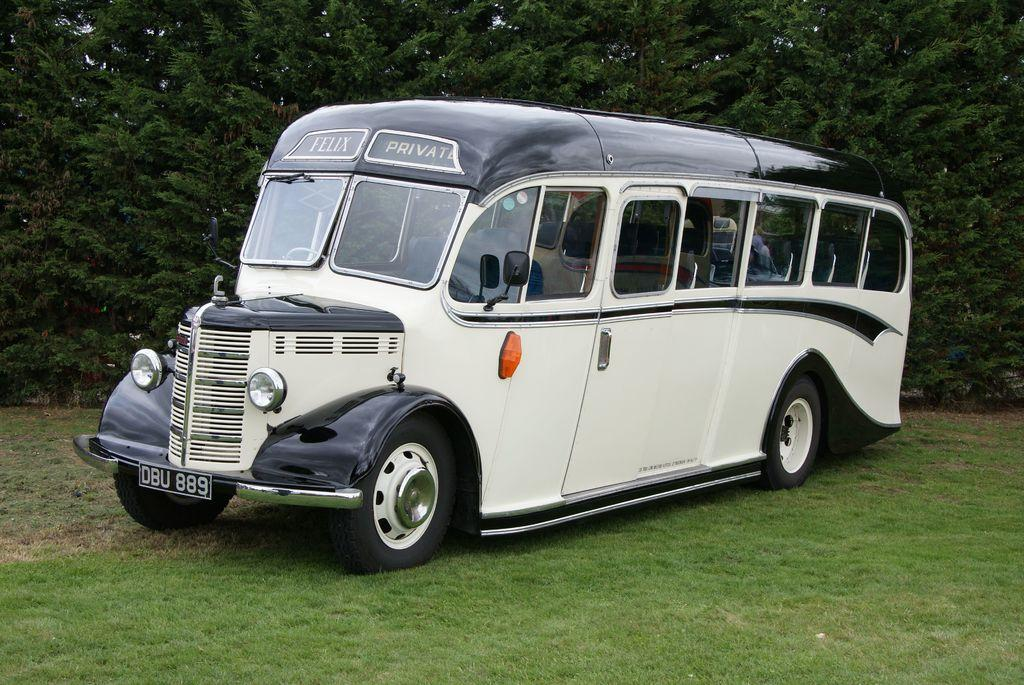<image>
Create a compact narrative representing the image presented. black and white bus with felix private above windshield and license plate of dbu 889 